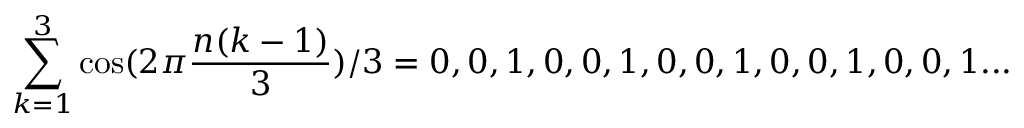<formula> <loc_0><loc_0><loc_500><loc_500>\sum _ { k = 1 } ^ { 3 } \cos ( 2 \pi { \frac { n ( k - 1 ) } { 3 } } ) / 3 = 0 , 0 , 1 , 0 , 0 , 1 , 0 , 0 , 1 , 0 , 0 , 1 , 0 , 0 , 1 \dots</formula> 